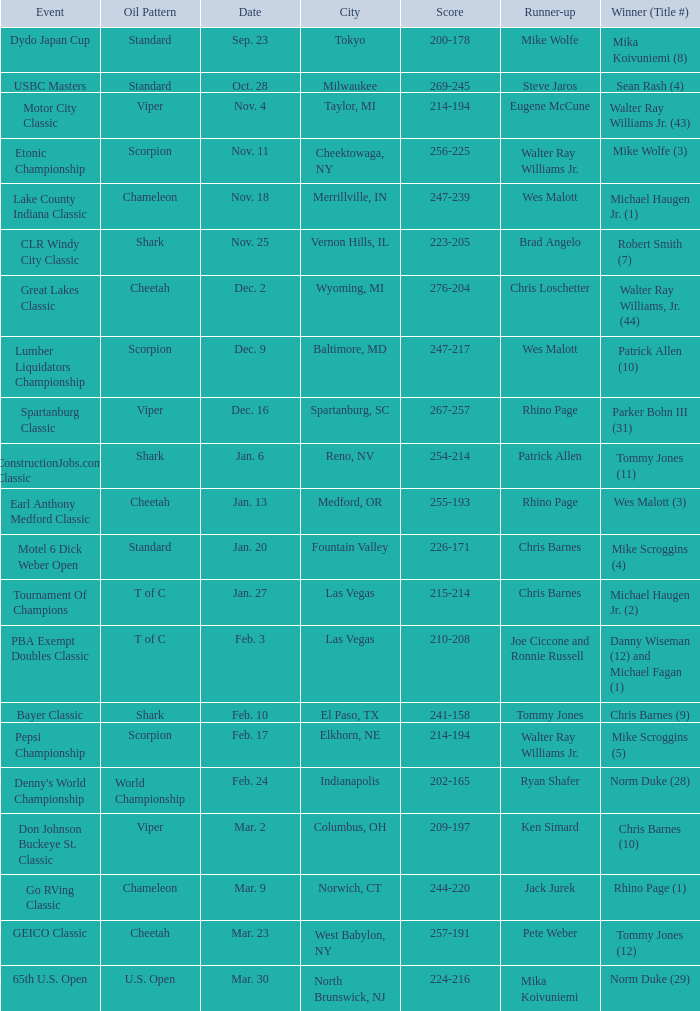Which Oil Pattern has a Winner (Title #) of mike wolfe (3)? Scorpion. 